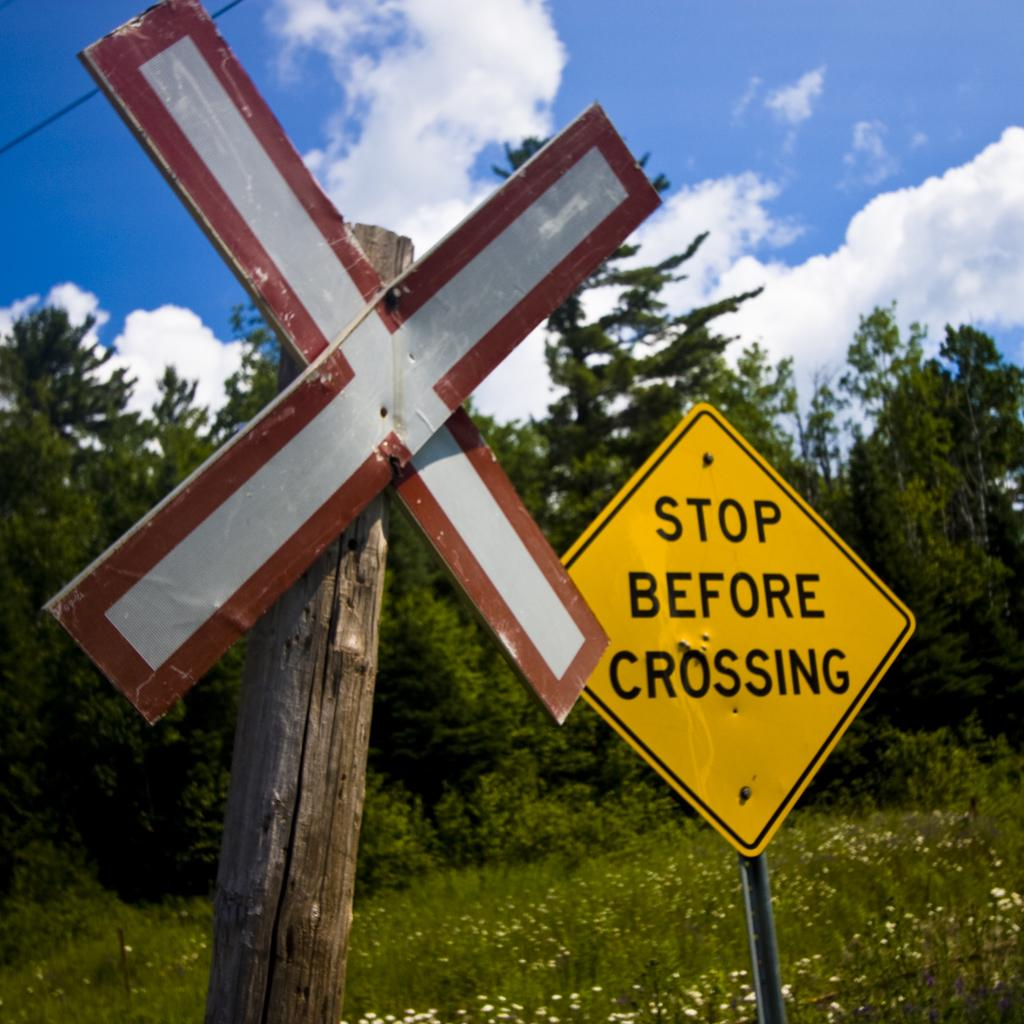<image>
Give a short and clear explanation of the subsequent image. A diamond yellow sign says "stop before crossing" next to a white X. 